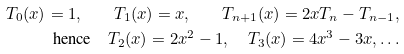<formula> <loc_0><loc_0><loc_500><loc_500>T _ { 0 } ( x ) = 1 , \quad T _ { 1 } ( x ) = x , \quad T _ { n + 1 } ( x ) = 2 x T _ { n } - T _ { n - 1 } , \\ \text {hence} \quad T _ { 2 } ( x ) = 2 x ^ { 2 } - 1 , \quad T _ { 3 } ( x ) = 4 x ^ { 3 } - 3 x , \dots</formula> 